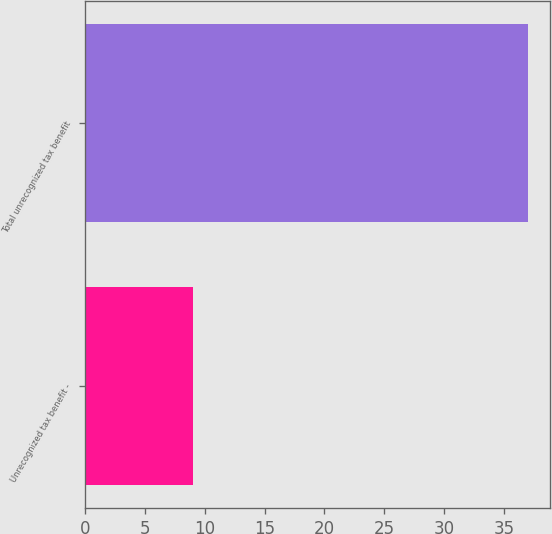Convert chart. <chart><loc_0><loc_0><loc_500><loc_500><bar_chart><fcel>Unrecognized tax benefit -<fcel>Total unrecognized tax benefit<nl><fcel>9<fcel>37<nl></chart> 